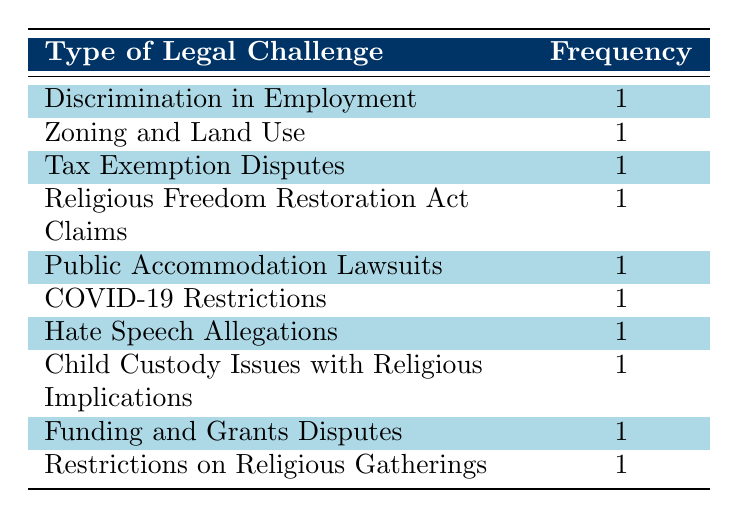What is the total number of different types of legal challenges listed in the table? The table lists ten distinct types of legal challenges faced by religious organizations from various years. Each type appears once, indicating that there are no repetitions.
Answer: 10 Which year had a legal challenge concerning COVID-19 restrictions? The table indicates that the legal challenge related to COVID-19 restrictions was faced by Faithful Assembly in the year 2020.
Answer: 2020 Is there a type of legal challenge that pertains to child custody issues? There is indeed a type of legal challenge called "Child Custody Issues with Religious Implications" listed in the table, which confirms the existence of such a challenge.
Answer: Yes How many organizations faced Discrimination in Employment challenges? According to the table, only one organization, Eagle Rock Baptist Church, faced a challenge related to Discrimination in Employment.
Answer: 1 Do the challenges related to Zoning and Land Use and Restrictions on Religious Gatherings have the same frequency? Both challenges have a frequency of 1, thus confirming that they are equal in number. Therefore, the answer is 'true'.
Answer: True If we consider the frequency, which legal challenge appears most frequently in the table? Each type of legal challenge is only listed once in the table, meaning they all share the same frequency of 1; hence, there is no most frequent challenge.
Answer: None Which organization faced the most recent legal challenge, according to the table? The most recent year in the table is 2023, where two organizations faced legal challenges; Saint Joseph’s Catholic Church dealt with Tax Exemption Disputes, and Community Outreach Church faced Funding and Grants Disputes.
Answer: 2023 What percentage of organizations faced legal challenges related to revenue? There are two relevant cases (Tax Exemption Disputes and Funding and Grants Disputes) out of ten total legal challenges, resulting in a calculation where (2/10) * 100 = 20%.
Answer: 20% List the legal challenges that pertain to public spaces or access issues. There are two types: "Public Accommodation Lawsuits" and "Restrictions on Religious Gatherings." Both address issues of access and public space, highlighting challenges that religious organizations encounter in public interactions.
Answer: Public Accommodation Lawsuits, Restrictions on Religious Gatherings 